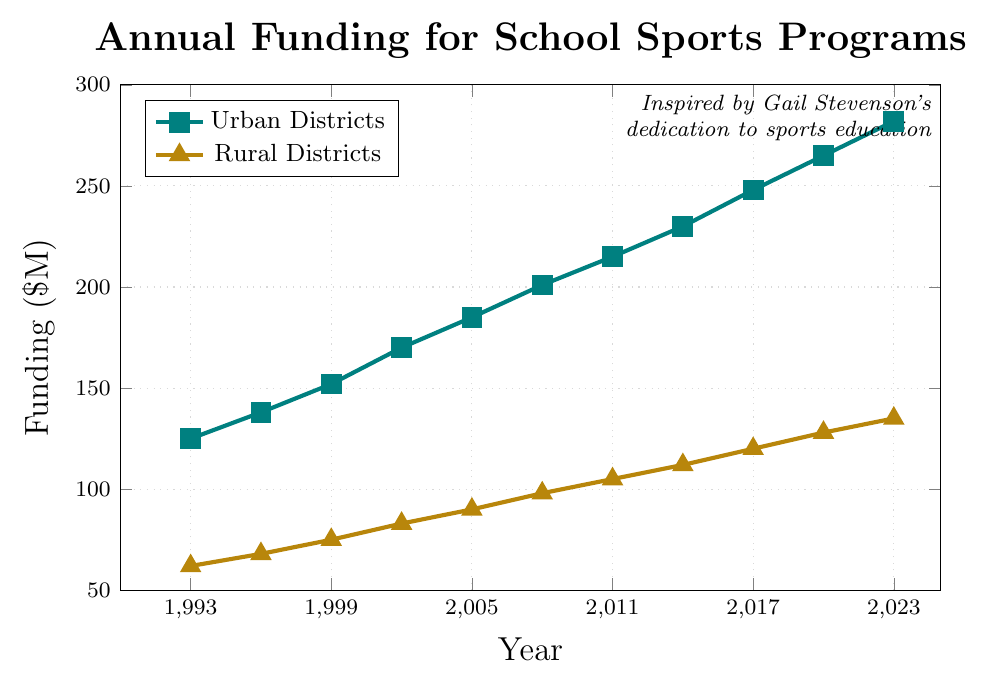What is the difference in funding between Urban and Rural Districts in 2023? In 2023, the funding for Urban Districts is $282M and for Rural Districts is $135M. The difference can be calculated as $282M - $135M.
Answer: $147M What is the average funding for Urban Districts from 1993 to 2023? To find the average, sum all the funding values from 1993 to 2023 for Urban Districts and divide by the number of years. The funding values are 125, 138, 152, 170, 185, 201, 215, 230, 248, 265, 282. The sum is 2211 and there are 11 values. 2211/11 = 201.
Answer: $201M In which year did Rural Districts first reach $100M in funding? By looking at the graph, we can see that the funding for Rural Districts reached $105M in 2011.
Answer: 2011 How much more funding did Urban Districts have compared to Rural Districts in 2005? In 2005, the funding for Urban Districts was $185M and for Rural Districts was $90M. The difference can be calculated as $185M - $90M.
Answer: $95M What is the visual difference in funding growth trends between Urban and Rural Districts? By observing the lines, both Urban and Rural Districts show a consistent upward trend in funding. However, Urban Districts generally have steeper slopes indicating a faster rate of increase compared to Rural Districts.
Answer: Urban growth faster Which year shows the smallest difference in funding between Urban and Rural Districts? By visually comparing the gaps between the lines, the smallest difference in funding is observed around 1993 where Urban funding is $125M and Rural funding is $62M, with a difference of $63M.
Answer: 1993 Compare the funding growth rate of Urban Districts between 1993-2003 and 2008-2018. Between 1993 and 2003, Urban funding grew from $125M to $170M, an increase of $45M over 10 years. Between 2008 and 2018, it went from $201M to $248M, an increase of $47M over 10 years. The growth rate is slightly higher from 2008 to 2018.
Answer: Growth rate higher 2008-2018 